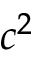Convert formula to latex. <formula><loc_0><loc_0><loc_500><loc_500>c ^ { 2 }</formula> 